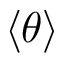<formula> <loc_0><loc_0><loc_500><loc_500>\langle \theta \rangle</formula> 